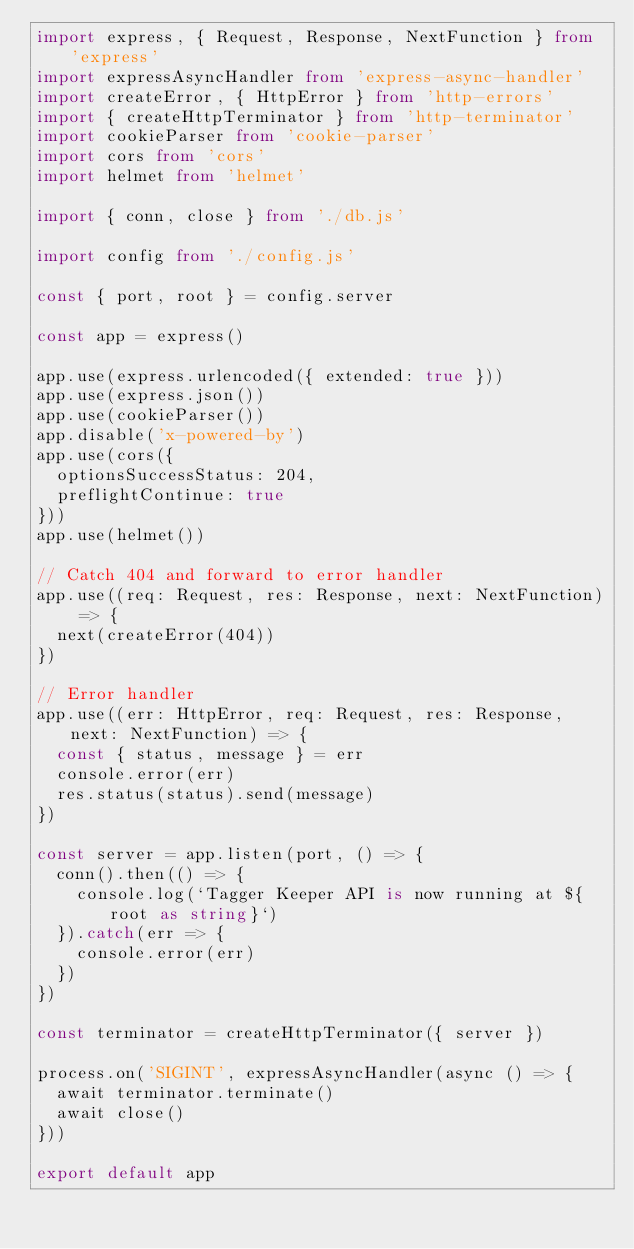<code> <loc_0><loc_0><loc_500><loc_500><_TypeScript_>import express, { Request, Response, NextFunction } from 'express'
import expressAsyncHandler from 'express-async-handler'
import createError, { HttpError } from 'http-errors'
import { createHttpTerminator } from 'http-terminator'
import cookieParser from 'cookie-parser'
import cors from 'cors'
import helmet from 'helmet'

import { conn, close } from './db.js'

import config from './config.js'

const { port, root } = config.server

const app = express()

app.use(express.urlencoded({ extended: true }))
app.use(express.json())
app.use(cookieParser())
app.disable('x-powered-by')
app.use(cors({
  optionsSuccessStatus: 204,
  preflightContinue: true
}))
app.use(helmet())

// Catch 404 and forward to error handler
app.use((req: Request, res: Response, next: NextFunction) => {
  next(createError(404))
})

// Error handler
app.use((err: HttpError, req: Request, res: Response, next: NextFunction) => {
  const { status, message } = err
  console.error(err)
  res.status(status).send(message)
})

const server = app.listen(port, () => {
  conn().then(() => {
    console.log(`Tagger Keeper API is now running at ${root as string}`)
  }).catch(err => {
    console.error(err)
  })
})

const terminator = createHttpTerminator({ server })

process.on('SIGINT', expressAsyncHandler(async () => {
  await terminator.terminate()
  await close()
}))

export default app
</code> 